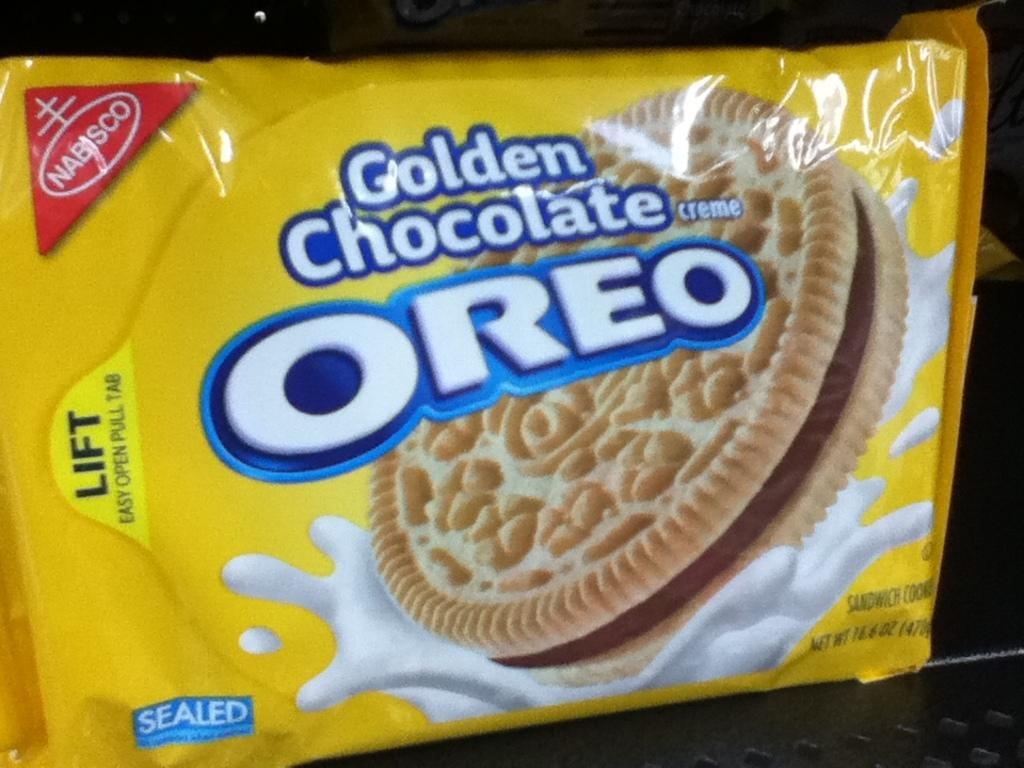What type of biscuit is featured in the image? The image features a yellow color OREO biscuit packet. Can you describe the object on which the OREO biscuit packet is placed? Unfortunately, the image does not provide enough information to describe the object on which the OREO biscuit packet is placed. Is there a deer eating the OREO biscuits in the image? No, there is no deer present in the image, and the biscuits are still in the packet. 